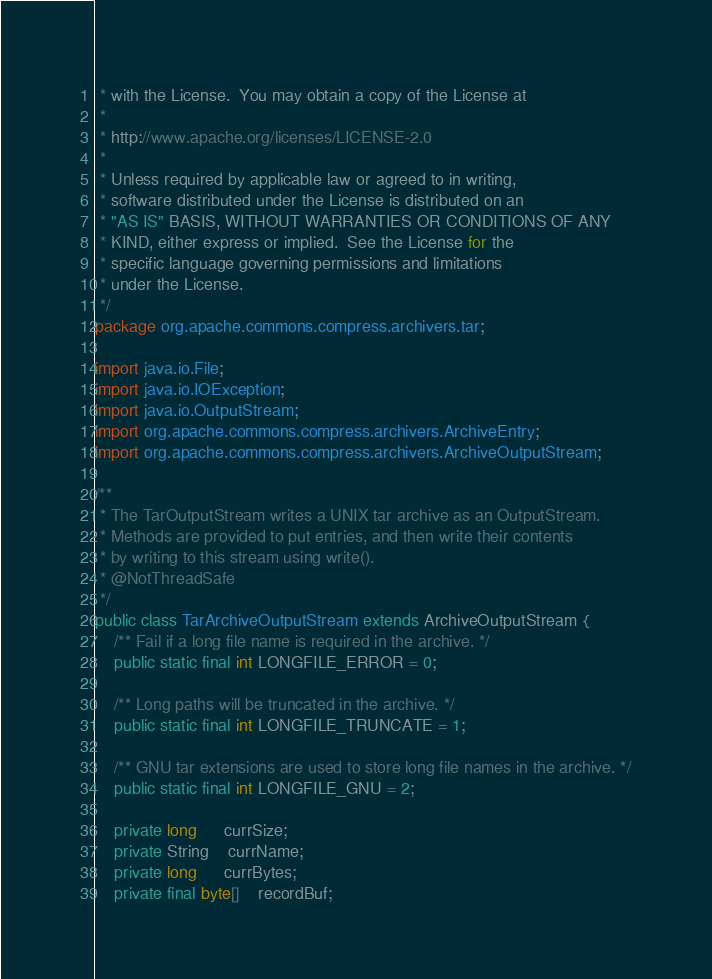Convert code to text. <code><loc_0><loc_0><loc_500><loc_500><_Java_> * with the License.  You may obtain a copy of the License at
 *
 * http://www.apache.org/licenses/LICENSE-2.0
 *
 * Unless required by applicable law or agreed to in writing,
 * software distributed under the License is distributed on an
 * "AS IS" BASIS, WITHOUT WARRANTIES OR CONDITIONS OF ANY
 * KIND, either express or implied.  See the License for the
 * specific language governing permissions and limitations
 * under the License.
 */
package org.apache.commons.compress.archivers.tar;

import java.io.File;
import java.io.IOException;
import java.io.OutputStream;
import org.apache.commons.compress.archivers.ArchiveEntry;
import org.apache.commons.compress.archivers.ArchiveOutputStream;

/**
 * The TarOutputStream writes a UNIX tar archive as an OutputStream.
 * Methods are provided to put entries, and then write their contents
 * by writing to this stream using write().
 * @NotThreadSafe
 */
public class TarArchiveOutputStream extends ArchiveOutputStream {
    /** Fail if a long file name is required in the archive. */
    public static final int LONGFILE_ERROR = 0;

    /** Long paths will be truncated in the archive. */
    public static final int LONGFILE_TRUNCATE = 1;

    /** GNU tar extensions are used to store long file names in the archive. */
    public static final int LONGFILE_GNU = 2;

    private long      currSize;
    private String    currName;
    private long      currBytes;
    private final byte[]    recordBuf;</code> 